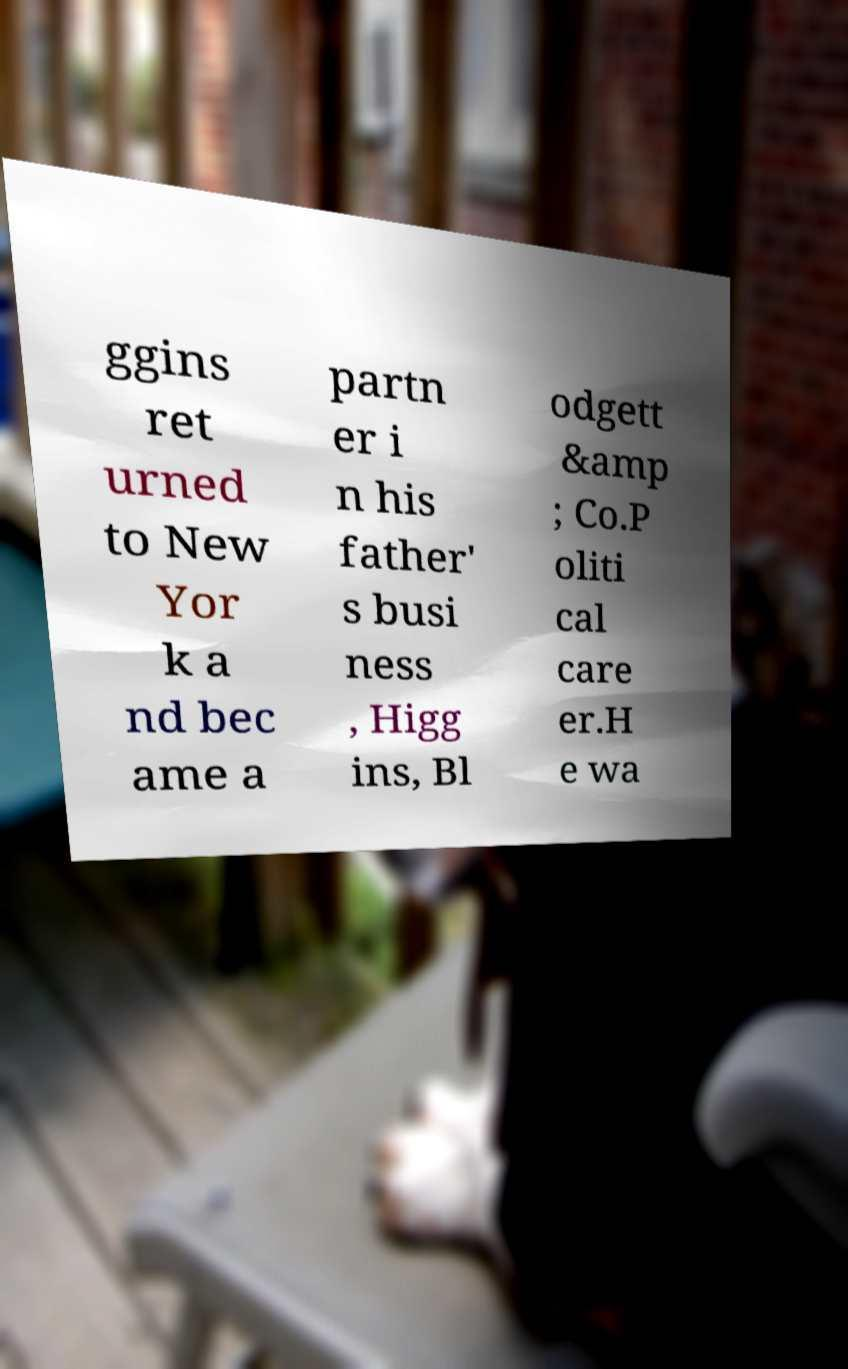Can you read and provide the text displayed in the image?This photo seems to have some interesting text. Can you extract and type it out for me? ggins ret urned to New Yor k a nd bec ame a partn er i n his father' s busi ness , Higg ins, Bl odgett &amp ; Co.P oliti cal care er.H e wa 